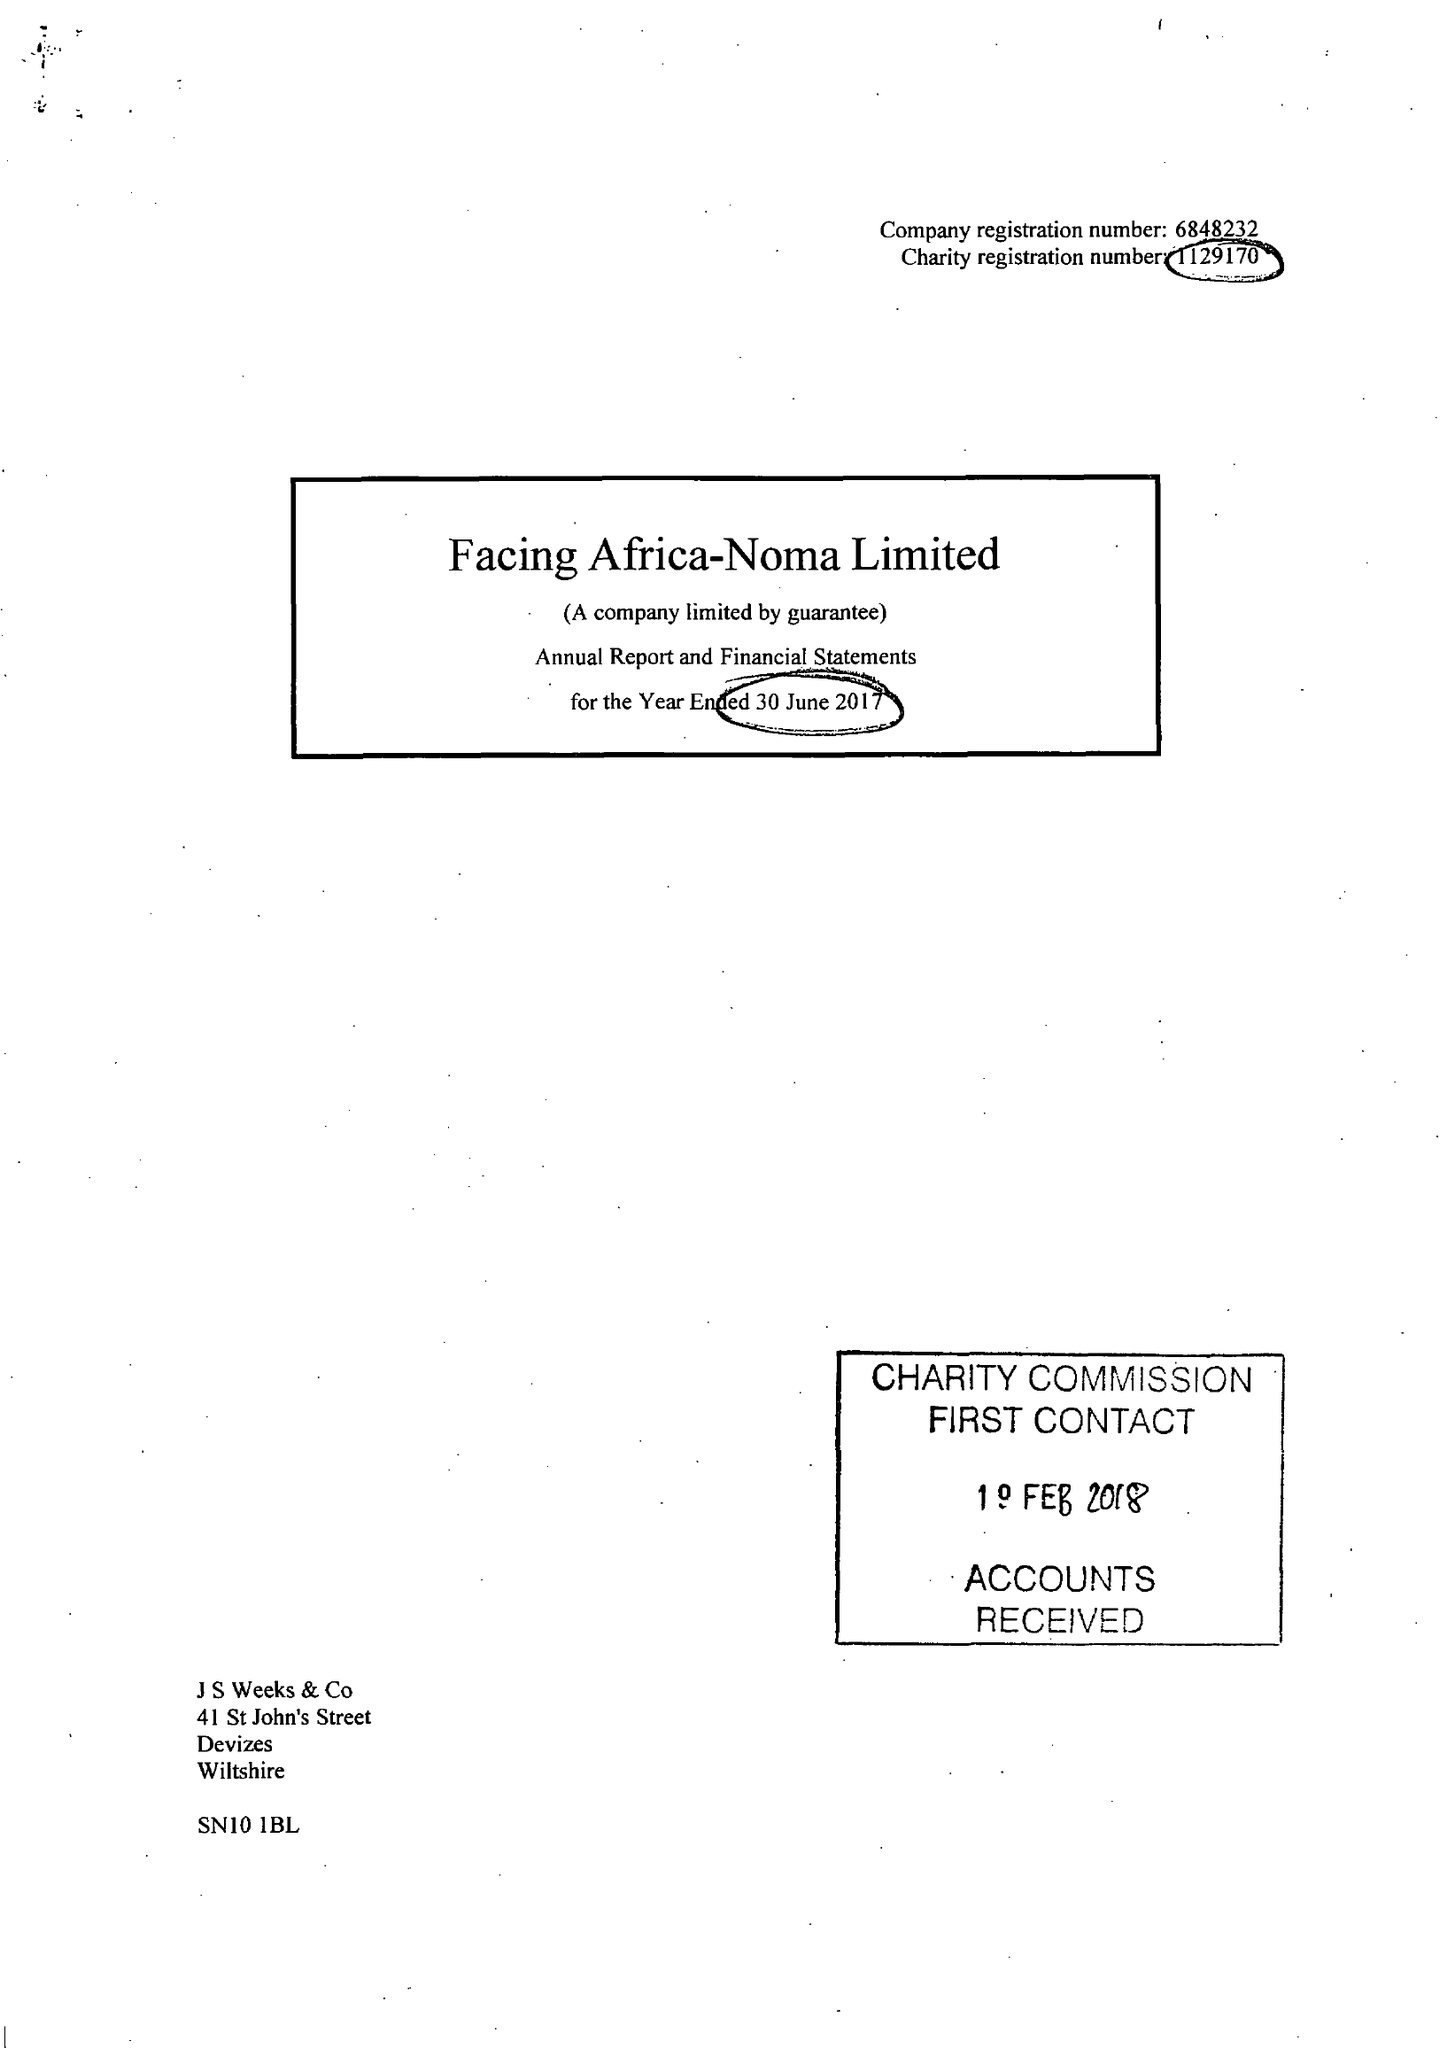What is the value for the charity_name?
Answer the question using a single word or phrase. Facing Africa Noma Ltd. 